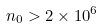<formula> <loc_0><loc_0><loc_500><loc_500>n _ { 0 } > 2 \times 1 0 ^ { 6 }</formula> 